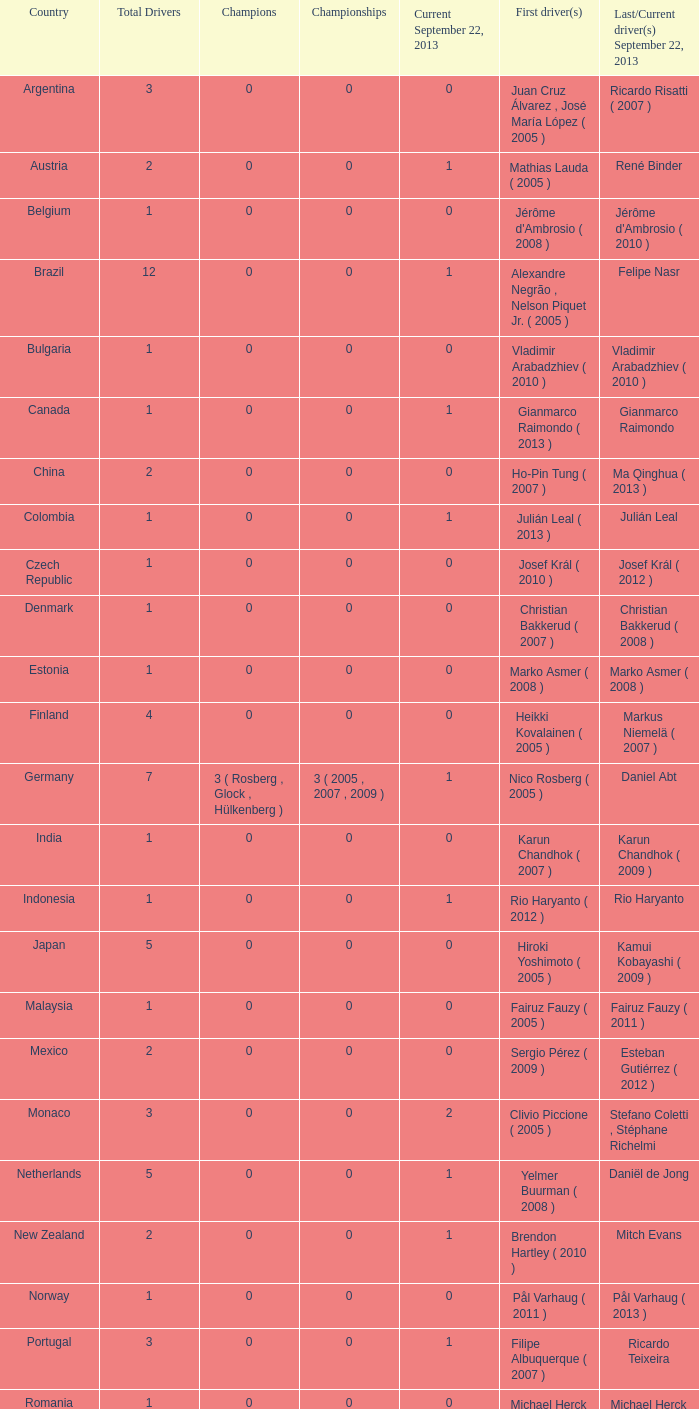When hiroki yoshimoto became the first driver in 2005, what was the number of champions? 0.0. I'm looking to parse the entire table for insights. Could you assist me with that? {'header': ['Country', 'Total Drivers', 'Champions', 'Championships', 'Current September 22, 2013', 'First driver(s)', 'Last/Current driver(s) September 22, 2013'], 'rows': [['Argentina', '3', '0', '0', '0', 'Juan Cruz Álvarez , José María López ( 2005 )', 'Ricardo Risatti ( 2007 )'], ['Austria', '2', '0', '0', '1', 'Mathias Lauda ( 2005 )', 'René Binder'], ['Belgium', '1', '0', '0', '0', "Jérôme d'Ambrosio ( 2008 )", "Jérôme d'Ambrosio ( 2010 )"], ['Brazil', '12', '0', '0', '1', 'Alexandre Negrão , Nelson Piquet Jr. ( 2005 )', 'Felipe Nasr'], ['Bulgaria', '1', '0', '0', '0', 'Vladimir Arabadzhiev ( 2010 )', 'Vladimir Arabadzhiev ( 2010 )'], ['Canada', '1', '0', '0', '1', 'Gianmarco Raimondo ( 2013 )', 'Gianmarco Raimondo'], ['China', '2', '0', '0', '0', 'Ho-Pin Tung ( 2007 )', 'Ma Qinghua ( 2013 )'], ['Colombia', '1', '0', '0', '1', 'Julián Leal ( 2013 )', 'Julián Leal'], ['Czech Republic', '1', '0', '0', '0', 'Josef Král ( 2010 )', 'Josef Král ( 2012 )'], ['Denmark', '1', '0', '0', '0', 'Christian Bakkerud ( 2007 )', 'Christian Bakkerud ( 2008 )'], ['Estonia', '1', '0', '0', '0', 'Marko Asmer ( 2008 )', 'Marko Asmer ( 2008 )'], ['Finland', '4', '0', '0', '0', 'Heikki Kovalainen ( 2005 )', 'Markus Niemelä ( 2007 )'], ['Germany', '7', '3 ( Rosberg , Glock , Hülkenberg )', '3 ( 2005 , 2007 , 2009 )', '1', 'Nico Rosberg ( 2005 )', 'Daniel Abt'], ['India', '1', '0', '0', '0', 'Karun Chandhok ( 2007 )', 'Karun Chandhok ( 2009 )'], ['Indonesia', '1', '0', '0', '1', 'Rio Haryanto ( 2012 )', 'Rio Haryanto'], ['Japan', '5', '0', '0', '0', 'Hiroki Yoshimoto ( 2005 )', 'Kamui Kobayashi ( 2009 )'], ['Malaysia', '1', '0', '0', '0', 'Fairuz Fauzy ( 2005 )', 'Fairuz Fauzy ( 2011 )'], ['Mexico', '2', '0', '0', '0', 'Sergio Pérez ( 2009 )', 'Esteban Gutiérrez ( 2012 )'], ['Monaco', '3', '0', '0', '2', 'Clivio Piccione ( 2005 )', 'Stefano Coletti , Stéphane Richelmi'], ['Netherlands', '5', '0', '0', '1', 'Yelmer Buurman ( 2008 )', 'Daniël de Jong'], ['New Zealand', '2', '0', '0', '1', 'Brendon Hartley ( 2010 )', 'Mitch Evans'], ['Norway', '1', '0', '0', '0', 'Pål Varhaug ( 2011 )', 'Pål Varhaug ( 2013 )'], ['Portugal', '3', '0', '0', '1', 'Filipe Albuquerque ( 2007 )', 'Ricardo Teixeira'], ['Romania', '1', '0', '0', '0', 'Michael Herck ( 2008 )', 'Michael Herck ( 2011 )'], ['Russia', '2', '0', '0', '0', 'Vitaly Petrov ( 2006 )', 'Mikhail Aleshin ( 2011 )'], ['Serbia', '1', '0', '0', '0', 'Miloš Pavlović ( 2008 )', 'Miloš Pavlović ( 2008 )'], ['South Africa', '1', '0', '0', '0', 'Adrian Zaugg ( 2007 )', 'Adrian Zaugg ( 2010 )'], ['Spain', '10', '0', '0', '2', 'Borja García , Sergio Hernández ( 2005 )', 'Sergio Canamasas , Dani Clos'], ['Sweden', '1', '0', '0', '1', 'Marcus Ericsson ( 2010 )', 'Marcus Ericsson'], ['Switzerland', '5', '0', '0', '2', 'Neel Jani ( 2005 )', 'Fabio Leimer , Simon Trummer'], ['Turkey', '2', '0', '0', '0', 'Can Artam ( 2005 )', 'Jason Tahincioglu ( 2007 )'], ['United Arab Emirates', '1', '0', '0', '0', 'Andreas Zuber ( 2006 )', 'Andreas Zuber ( 2009 )'], ['United States', '4', '0', '0', '2', 'Scott Speed ( 2005 )', 'Jake Rosenzweig , Alexander Rossi']]} 